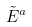<formula> <loc_0><loc_0><loc_500><loc_500>\tilde { E } ^ { a }</formula> 